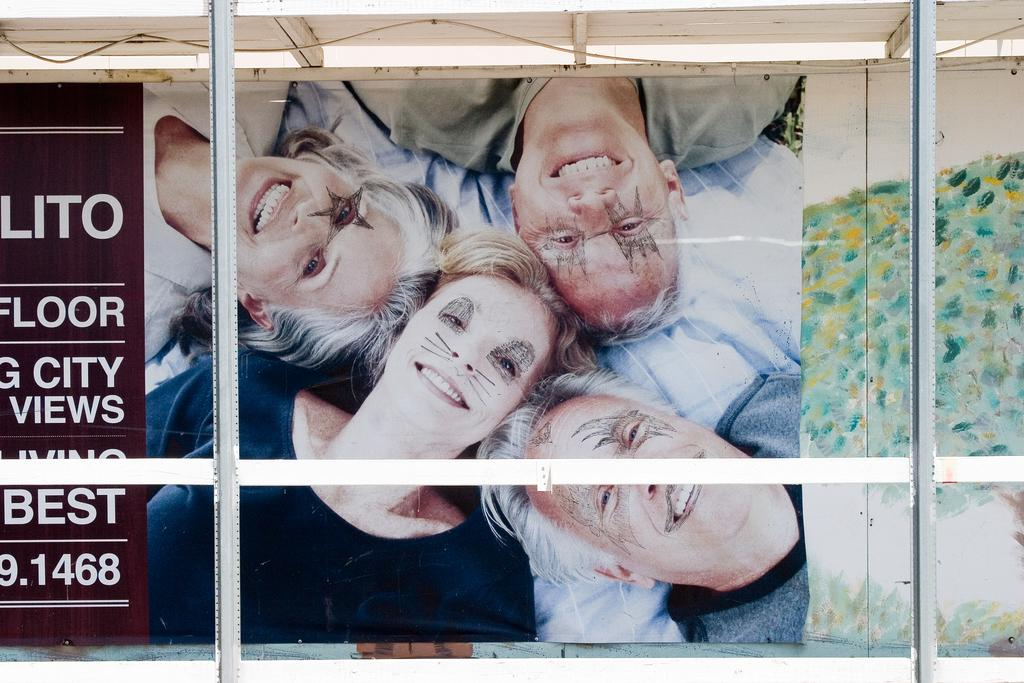What is happening in the image involving a group of people? There is a group of people in the image, and they are smiling. Can you describe the appearance of the people in the image? The people in the image are wearing face paint. Is there any text or writing in the image? Yes, there is some matter written in the left corner of the image. What type of birds can be seen flying through the hole in the image? There is no hole or birds present in the image. 